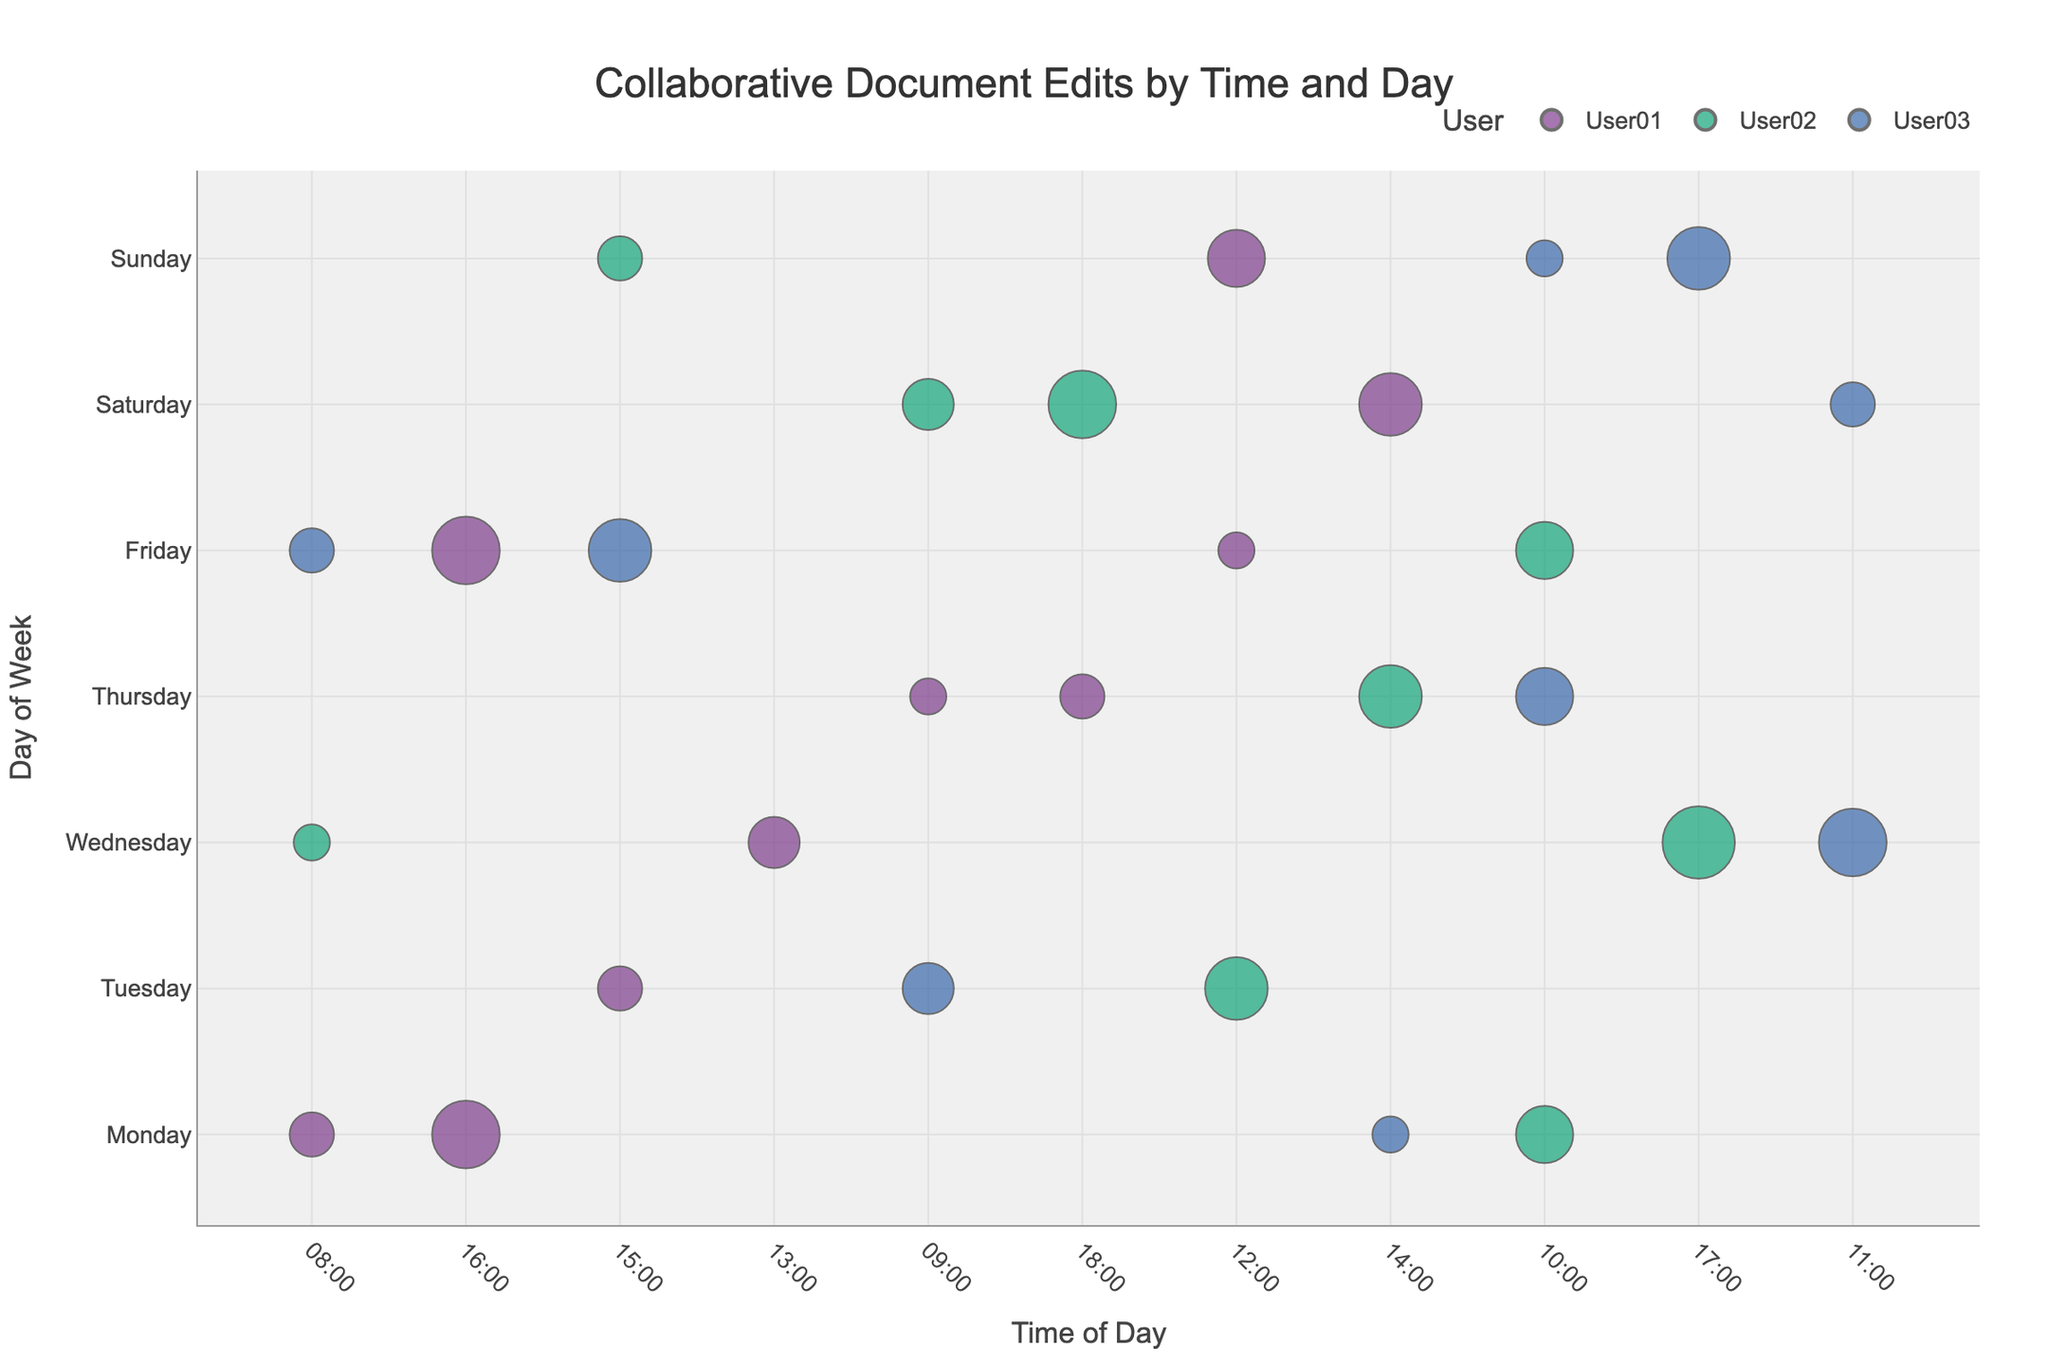What's the title of the bubble chart? The title is usually located at the top of the chart in a larger font. In this chart, it specifies what the visualization represents.
Answer: Collaborative Document Edits by Time and Day Which time slot on Monday had the highest number of edits? Look for the largest bubble on the "Monday" row along the x-axis.
Answer: 16:00 How many edits did User02 make on Thursday at 14:00? Find the bubble with User02's color on the "Thursday" row at the "14:00" column and check its size.
Answer: 6 On which day did User03 make the most edits, and at what time? Look at the largest bubble of User03’s color and identify its position on the y-axis for the day and x-axis for the time.
Answer: Wednesday, 11:00 Compare the edits made by User01 and User02 on Tuesday at 15:00 and 12:00, respectively. Who made more edits? Check the sizes of the bubbles for each user at the specified times.
Answer: User02 List all time slots where User01 has high importance edits. Identify bubbles with User01’s color that also have a large size and a high importance value indicated in the hover data or legend.
Answer: Monday 16:00, Friday 16:00, Saturday 14:00 What is the average number of edits at 08:00 across all days in the week? For each day at 08:00, sum the number of edits and divide by the count of unique days.
Answer: (3 + 2 + 3)/3 = 8/3 ≈ 2.67 On which day and time did the lowest edits with medium importance occur? Find bubbles with medium importance, then look for the smallest bubble among them.
Answer: Monday, 14:00 Which user’s edits show a clear preference for weekday mornings? Identify the user with the most bubbles clustered in the morning times (before 12:00) on weekdays.
Answer: User02 How does the distribution of edit importance vary throughout the week for User03? Analyze the importance values for User03's bubbles distributed through the week, noting the count and size of bubbles with different importance levels.
Answer: High on Wednesday and Sunday, Medium on Thursday and Friday, Low on Friday and Saturday 